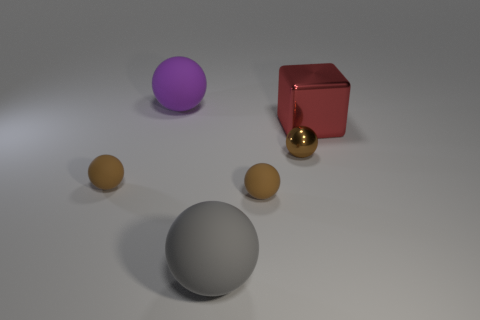What is the shape of the red metallic thing?
Your answer should be very brief. Cube. What number of blocks are tiny things or blue rubber objects?
Offer a terse response. 0. Are there the same number of gray spheres that are behind the gray rubber thing and purple objects that are on the right side of the purple object?
Your response must be concise. Yes. There is a tiny brown thing that is to the right of the tiny matte object that is on the right side of the big purple rubber thing; how many gray objects are behind it?
Make the answer very short. 0. There is a metallic cube; is it the same color as the small rubber thing right of the purple matte ball?
Offer a very short reply. No. Are there more red blocks that are behind the small brown metallic thing than gray matte balls?
Ensure brevity in your answer.  No. How many things are either big objects that are in front of the small brown metal object or small brown shiny objects that are behind the gray thing?
Provide a succinct answer. 2. There is a brown thing that is the same material as the red cube; what is its size?
Offer a very short reply. Small. There is a large rubber object that is behind the large red metal cube; does it have the same shape as the red metal thing?
Offer a very short reply. No. What number of red objects are either objects or large shiny things?
Provide a succinct answer. 1. 